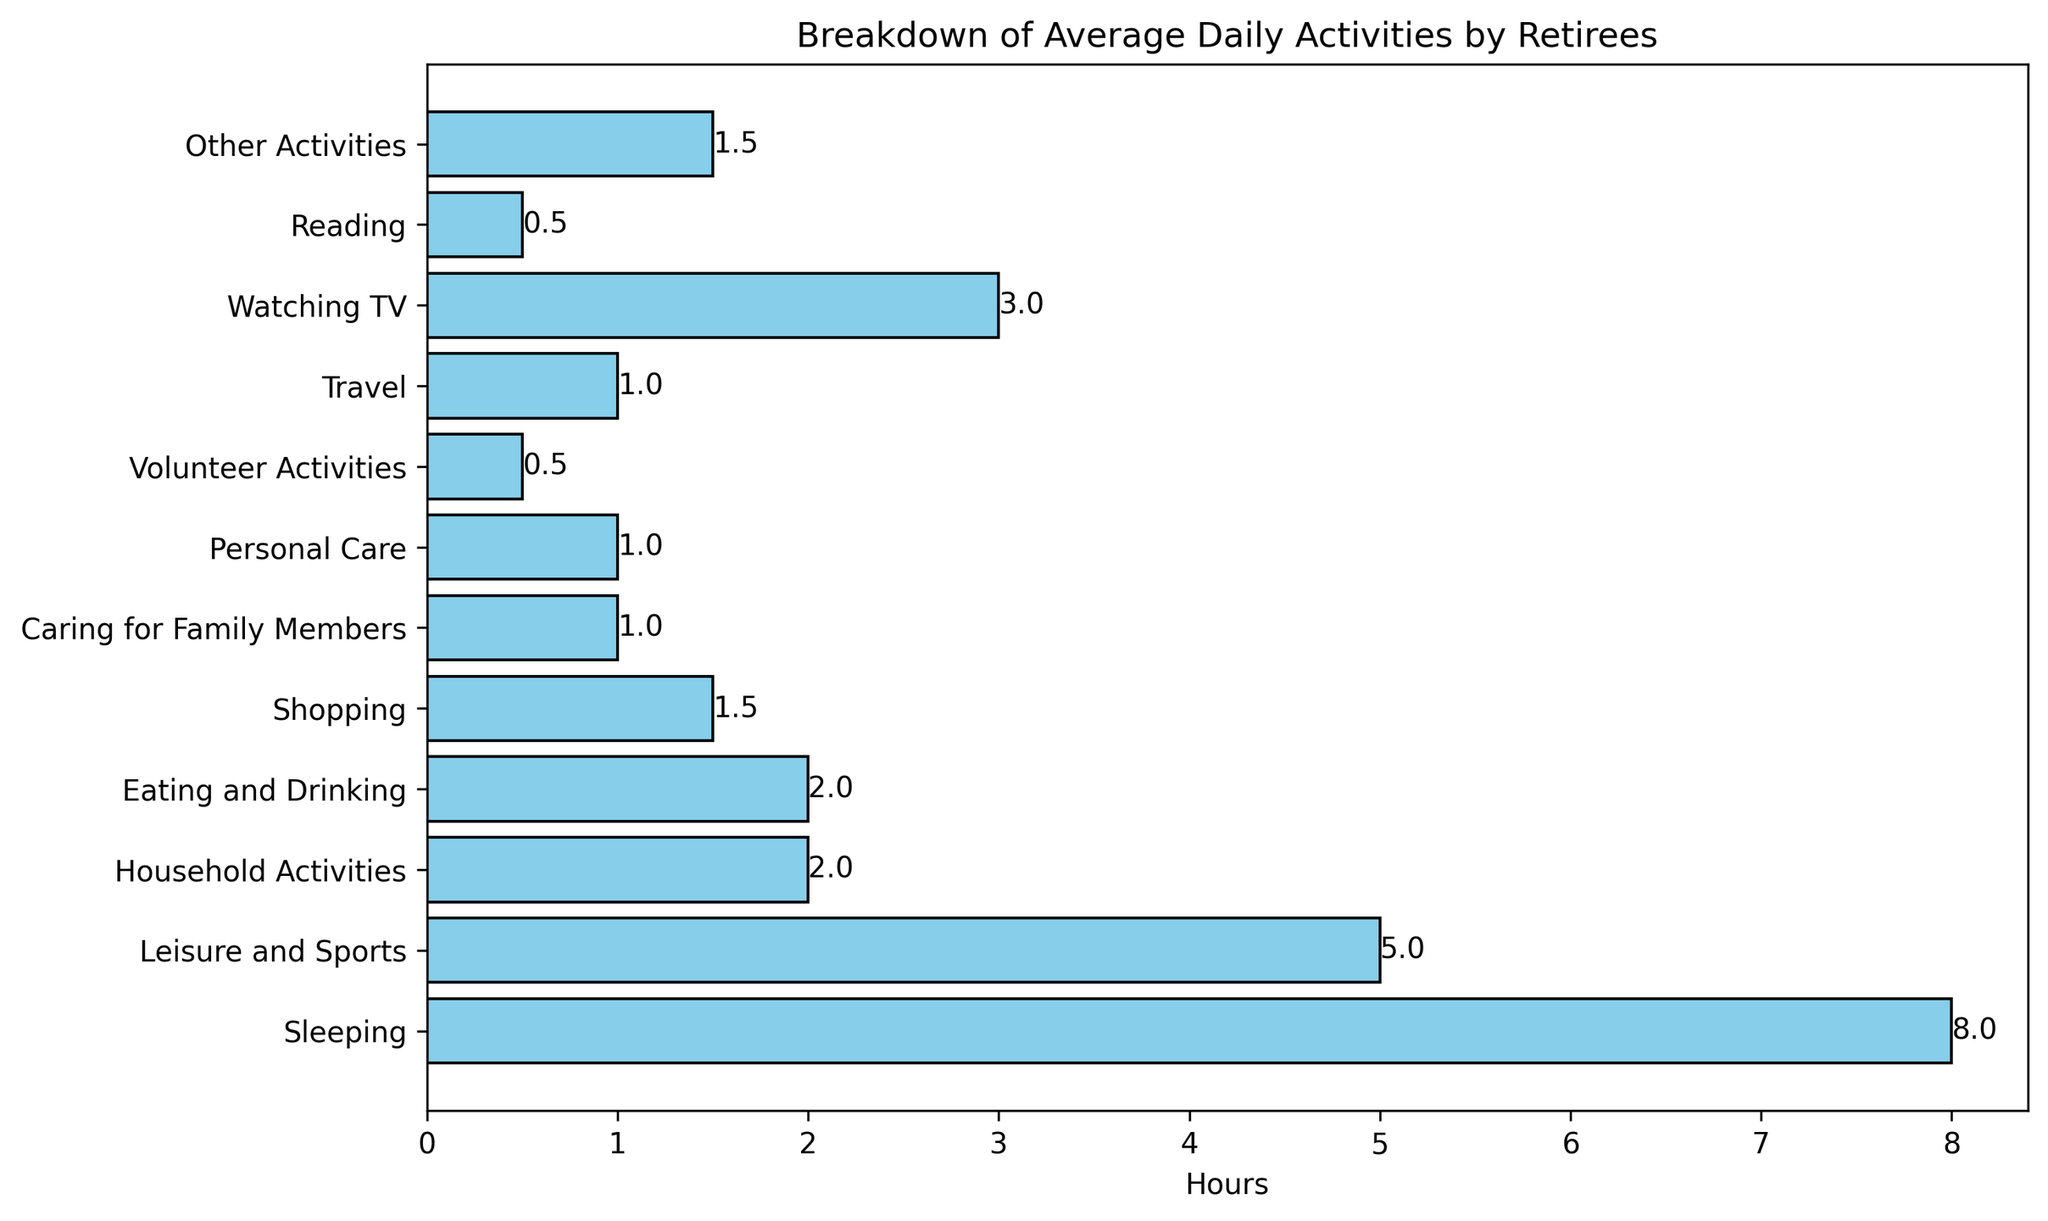What activity do retirees spend the most hours on? Looking at the bar chart, the longest bar is associated with the "Sleeping" category, indicating retirees spend the most hours on that activity.
Answer: Sleeping How many more hours do retirees spend on Sleeping compared to Household Activities? Retirees spend 8 hours on Sleeping and 2 hours on Household Activities. The difference is 8 - 2 = 6 hours.
Answer: 6 hours Which activity occupies exactly 1.5 hours of retirees' daily schedule? The bar labeled "Shopping" and "Other Activities" both show that retirees spend 1.5 hours on these activities.
Answer: Shopping, Other Activities Combine the hours spent on Leisure and Sports, Watching TV, and Reading. What is the total? The hours spent on Leisure and Sports is 5, Watching TV is 3, and Reading is 0.5. Summing these values results in 5 + 3 + 0.5 = 8.5 hours.
Answer: 8.5 hours Do retirees spend more hours on Eating and Drinking or on Shopping? The bar showing hours spent on Eating and Drinking is at 2 hours, while Shopping is at 1.5 hours. So, they spend more time on Eating and Drinking.
Answer: Eating and Drinking Which activities do retirees spend less than 1 hour on? The bars for Volunteer Activities (0.5 hours) and Reading (0.5 hours) indicate these activities occupy less than 1 hour.
Answer: Volunteer Activities, Reading How many hours, in total, do retirees spend on Personal Care and Caring for Family Members? Retirees spend 1 hour on Personal Care and 1 hour on Caring for Family Members. Therefore, the total is 1 + 1 = 2 hours.
Answer: 2 hours Which is longer: the bar for Watching TV or the bar for Leisure and Sports? The bar for Watching TV is 3 hours long, while the bar for Leisure and Sports is 5 hours long. So, the Leisure and Sports bar is longer.
Answer: Leisure and Sports Calculate the average time spent on Household Activities, Shopping, and Volunteering. The hours spent on Household Activities is 2, Shopping is 1.5, and Volunteering is 0.5. The average is (2 + 1.5 + 0.5) / 3 ≈ 1.33 hours.
Answer: 1.33 hours What’s the combined time retirees allocate to Travel and Other Activities? Retirees spend 1 hour on Travel and 1.5 hours on Other Activities. Adding these together results in 1 + 1.5 = 2.5 hours.
Answer: 2.5 hours 